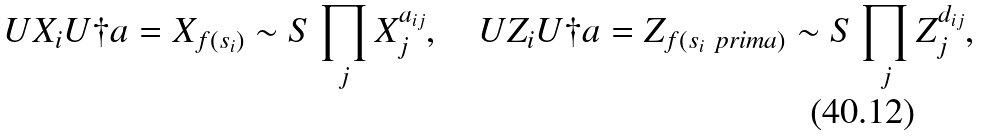<formula> <loc_0><loc_0><loc_500><loc_500>U X _ { i } U \dag a = X _ { f ( s _ { i } ) } \sim S \prod _ { j } X _ { j } ^ { a _ { i j } } , \quad U Z _ { i } U \dag a = Z _ { f ( s _ { i } \ p r i m a ) } \sim S \prod _ { j } Z _ { j } ^ { d _ { i j } } ,</formula> 